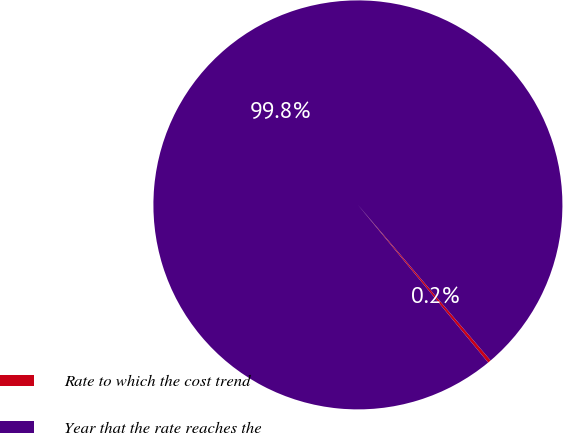Convert chart to OTSL. <chart><loc_0><loc_0><loc_500><loc_500><pie_chart><fcel>Rate to which the cost trend<fcel>Year that the rate reaches the<nl><fcel>0.25%<fcel>99.75%<nl></chart> 